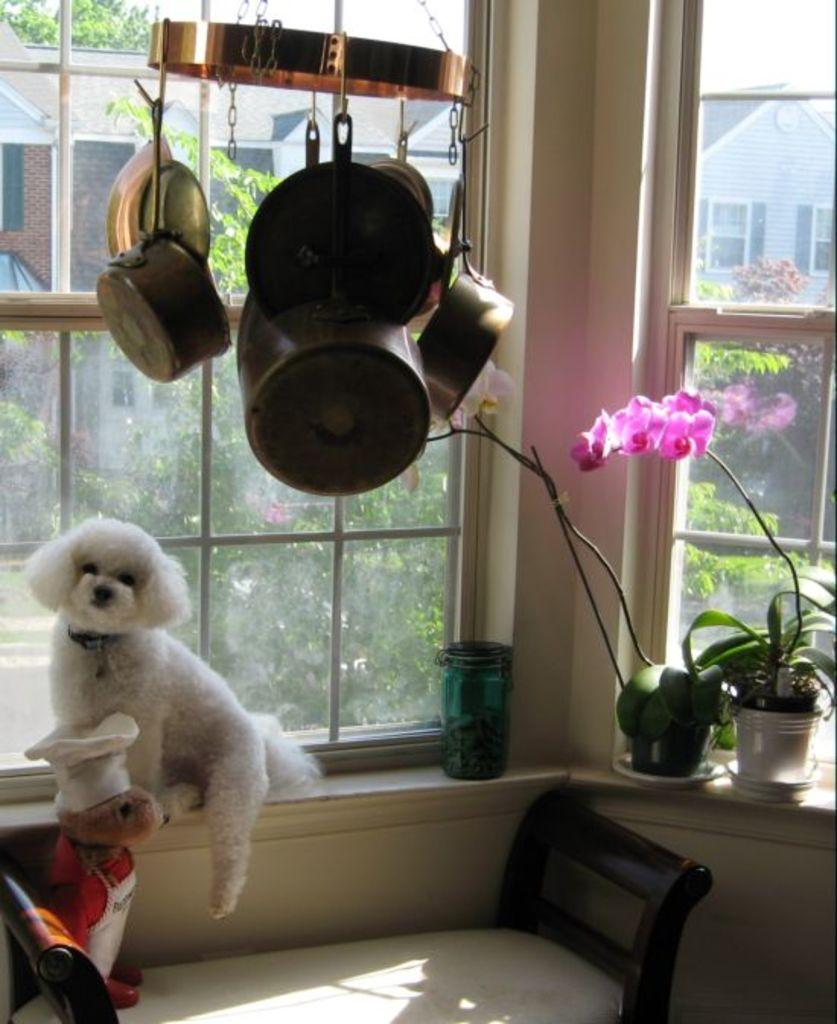What objects are located on the left side of the image? There are toys on the left side of the image. How many windows can be seen in the image? There are many windows in the image. What type of vegetation is on the right side of the image? There is a plant on the right side of the image. What structure is visible in the background of the image? There is a house visible in the background of the image. What type of lamp is visible on the plant in the image? There is no lamp present on the plant in the image. How many cards are being played by the toys in the image? There are no cards or toys playing in the image; it only shows toys on the left side and a plant on the right side. 